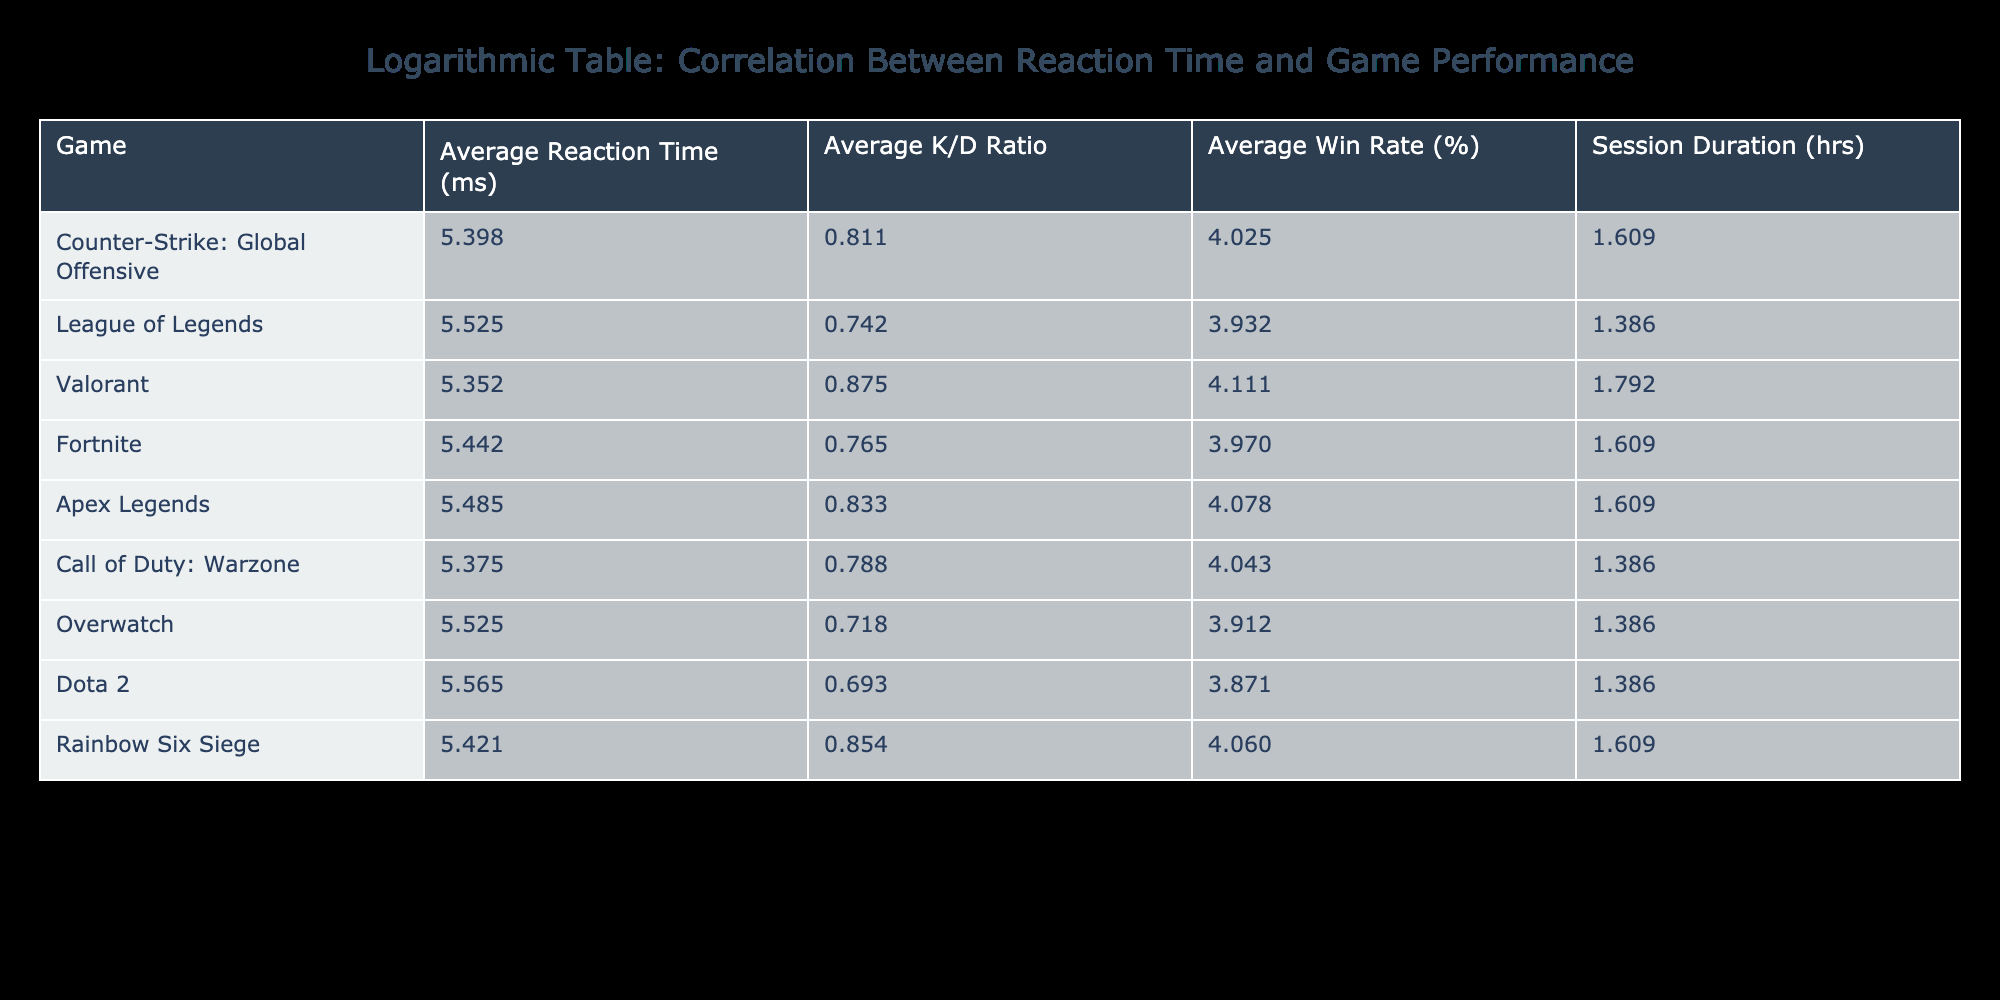What is the average reaction time for Counter-Strike: Global Offensive? The table lists the average reaction time for Counter-Strike: Global Offensive as 220 ms.
Answer: 220 ms Which game has the highest average K/D ratio, and what is that ratio? The average K/D ratios are listed in the table. By comparing values, Valorant has the highest average K/D ratio of 1.40.
Answer: 1.40 Is the average win rate for League of Legends higher than that for Dota 2? League of Legends has an average win rate of 50%, while Dota 2 has an average win rate of 47%. Since 50% is greater than 47%, the answer is yes.
Answer: Yes What is the total session duration (in hours) for all the games listed? The session durations are summed as follows: 4 + 3 + 5 + 4 + 4 + 3 + 3 + 3 + 4 = 33 hours.
Answer: 33 hours What is the game with the second lowest average reaction time and its corresponding average K/D ratio? The second lowest average reaction time is for Call of Duty: Warzone at 215 ms, and its average K/D ratio is 1.20.
Answer: 215 ms, 1.20 Which game has a higher average win rate: Apex Legends or Fortnite? Apex Legends has an average win rate of 58%, while Fortnite has an average win rate of 52%. Since 58% is greater than 52%, Apex Legends has a higher win rate.
Answer: Apex Legends If players wanted to minimize reaction time, which game should they choose based on this data? The game with the lowest average reaction time is Valorant with 210 ms, so players seeking to minimize reaction time should choose Valorant.
Answer: Valorant What is the difference in average win rate between Rainbow Six Siege and Overwatch? The average win rate for Rainbow Six Siege is 57% and for Overwatch is 49%. The difference is 57% - 49% = 8%.
Answer: 8% 